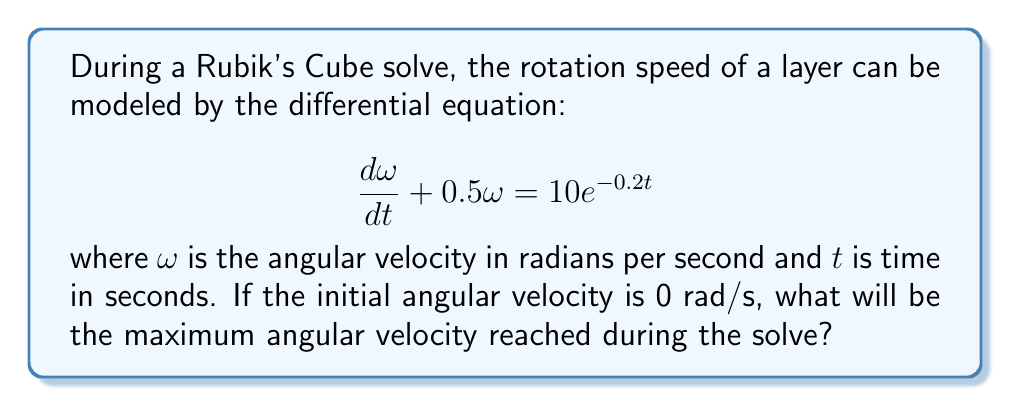Solve this math problem. To solve this problem, we need to follow these steps:

1) First, we recognize this as a first-order linear differential equation in the form:

   $$\frac{dy}{dx} + P(x)y = Q(x)$$

   where $P(x) = 0.5$ and $Q(x) = 10e^{-0.2t}$

2) The general solution for this type of equation is:

   $$y = e^{-\int P(x)dx} (\int Q(x)e^{\int P(x)dx}dx + C)$$

3) Let's solve each part:
   
   $\int P(x)dx = \int 0.5 dt = 0.5t$
   
   $e^{\int P(x)dx} = e^{0.5t}$

4) Now, we can rewrite our solution:

   $$ω = e^{-0.5t} (\int 10e^{-0.2t} \cdot e^{0.5t}dt + C)$$

5) Simplify the integral:

   $$ω = e^{-0.5t} (\int 10e^{0.3t}dt + C)$$

6) Solve the integral:

   $$ω = e^{-0.5t} (\frac{10}{0.3}e^{0.3t} + C)$$

7) Apply the initial condition $ω(0) = 0$:

   $$0 = \frac{10}{0.3} + C$$
   $$C = -\frac{10}{0.3}$$

8) Our final solution is:

   $$ω = \frac{10}{0.3}(e^{-0.2t} - e^{-0.5t})$$

9) To find the maximum angular velocity, we need to find where $\frac{dω}{dt} = 0$:

   $$\frac{dω}{dt} = \frac{10}{0.3}(-0.2e^{-0.2t} + 0.5e^{-0.5t}) = 0$$

10) Solving this equation:

    $$e^{0.3t} = \frac{5}{2}$$
    $$t = \frac{\ln(\frac{5}{2})}{0.3} \approx 3.07 \text{ seconds}$$

11) Plugging this time back into our solution for $ω$:

    $$ω_{max} = \frac{10}{0.3}(e^{-0.2(3.07)} - e^{-0.5(3.07)}) \approx 8.15 \text{ rad/s}$$
Answer: The maximum angular velocity reached during the solve is approximately 8.15 rad/s. 